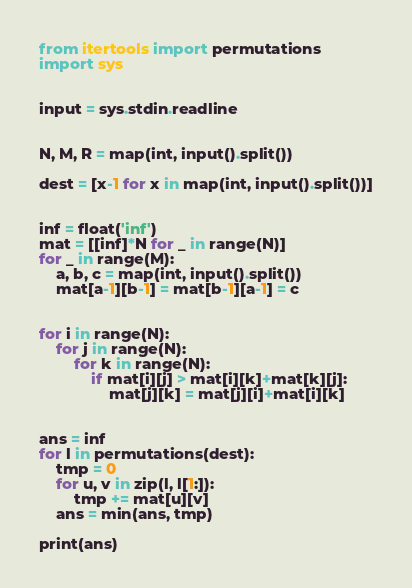<code> <loc_0><loc_0><loc_500><loc_500><_Python_>from itertools import permutations
import sys


input = sys.stdin.readline


N, M, R = map(int, input().split())

dest = [x-1 for x in map(int, input().split())]


inf = float('inf')
mat = [[inf]*N for _ in range(N)]
for _ in range(M):
    a, b, c = map(int, input().split())
    mat[a-1][b-1] = mat[b-1][a-1] = c


for i in range(N):
    for j in range(N):
        for k in range(N):
            if mat[i][j] > mat[i][k]+mat[k][j]:
                mat[j][k] = mat[j][i]+mat[i][k]


ans = inf
for l in permutations(dest):
    tmp = 0
    for u, v in zip(l, l[1:]):
        tmp += mat[u][v]
    ans = min(ans, tmp)

print(ans)
</code> 